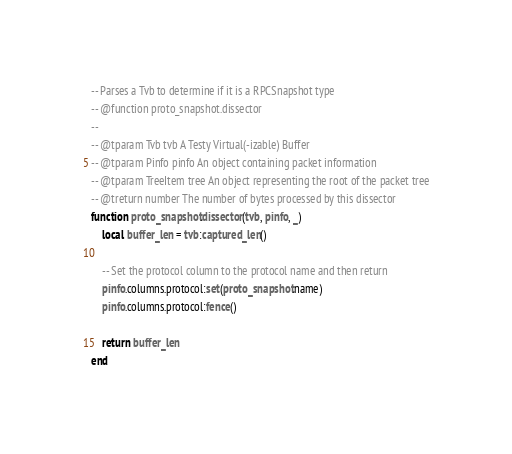<code> <loc_0><loc_0><loc_500><loc_500><_Lua_>-- Parses a Tvb to determine if it is a RPCSnapshot type
-- @function proto_snapshot.dissector
--
-- @tparam Tvb tvb A Testy Virtual(-izable) Buffer
-- @tparam Pinfo pinfo An object containing packet information
-- @tparam TreeItem tree An object representing the root of the packet tree
-- @treturn number The number of bytes processed by this dissector
function proto_snapshot.dissector(tvb, pinfo, _)
    local buffer_len = tvb:captured_len()

    -- Set the protocol column to the protocol name and then return
    pinfo.columns.protocol:set(proto_snapshot.name)
    pinfo.columns.protocol:fence()

    return buffer_len
end
</code> 